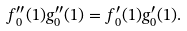<formula> <loc_0><loc_0><loc_500><loc_500>f _ { 0 } ^ { \prime \prime } ( 1 ) g _ { 0 } ^ { \prime \prime } ( 1 ) = f _ { 0 } ^ { \prime } ( 1 ) g _ { 0 } ^ { \prime } ( 1 ) .</formula> 